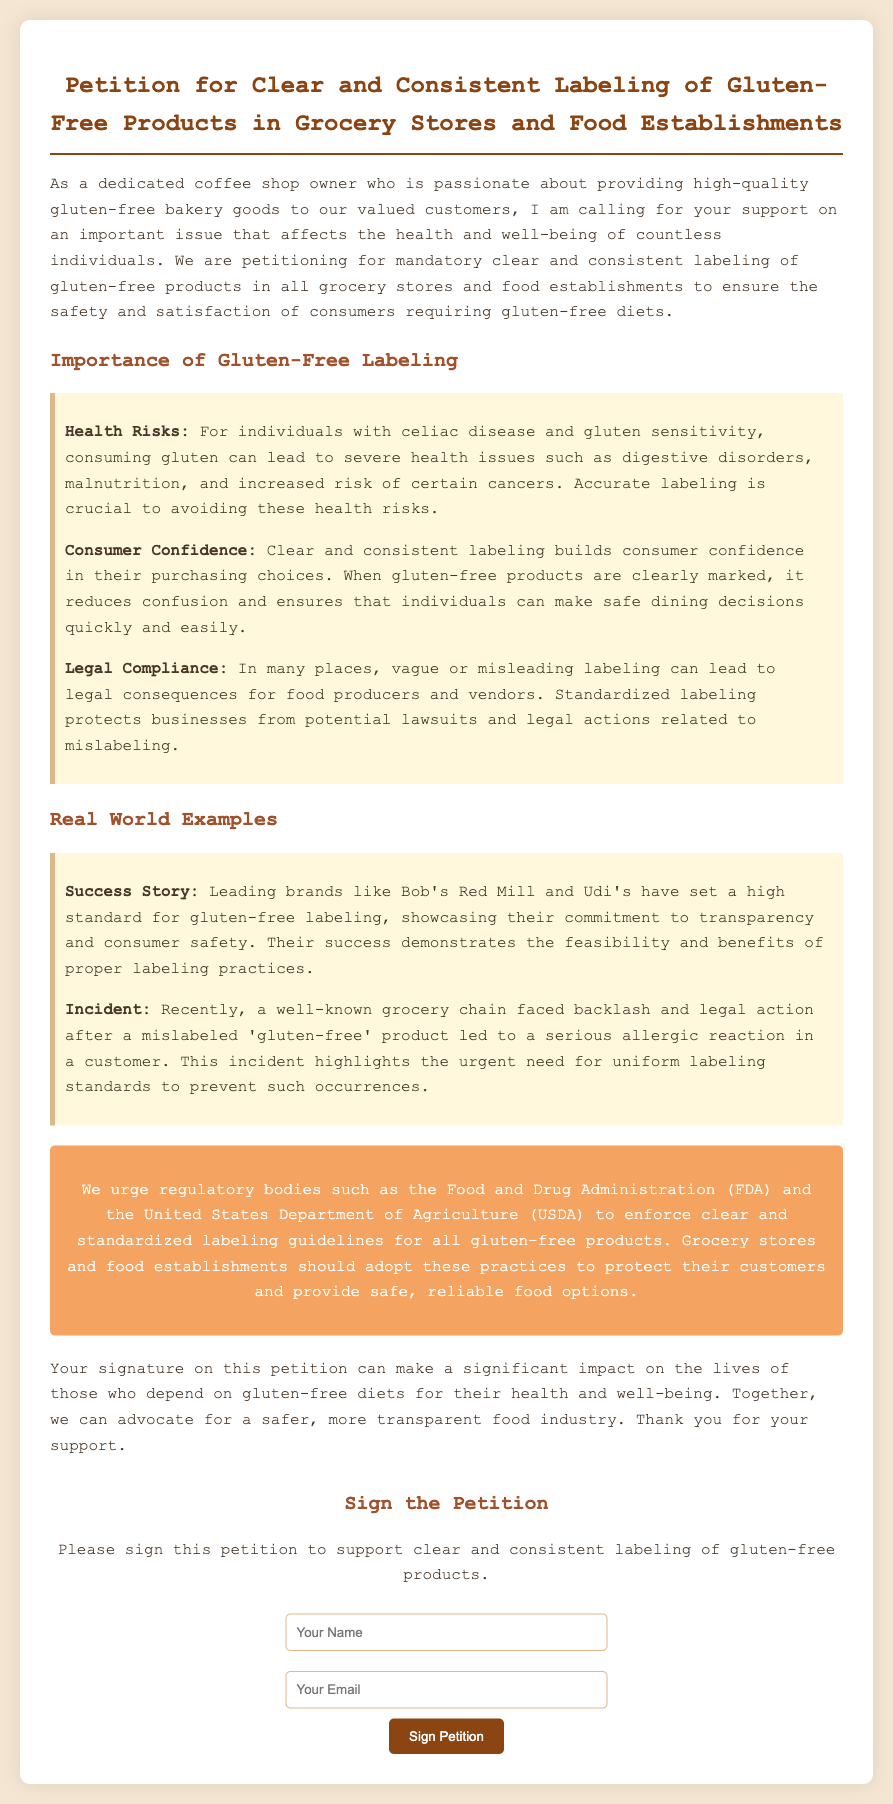What is the title of the petition? The title of the petition is stated in the header of the document.
Answer: Petition for Clear and Consistent Labeling of Gluten-Free Products in Grocery Stores and Food Establishments What are some health risks for individuals with gluten sensitivity? The document outlines specific health risks that individuals with gluten sensitivity may face.
Answer: Digestive disorders, malnutrition, and increased risk of certain cancers Which brands are mentioned as success stories for gluten-free labeling? The document provides examples of brands that have successfully implemented gluten-free labeling.
Answer: Bob's Red Mill and Udi's What does the call-to-action urge regulatory bodies to do? The call-to-action section specifies what is being requested from regulatory bodies.
Answer: Enforce clear and standardized labeling guidelines for all gluten-free products How many specific examples are provided in the section on real-world examples? The document includes a count of examples related to gluten-free labeling practices.
Answer: Two What type of form is included in the petition? The petition includes a specific element used to gather signatures.
Answer: A signature form What color is the background of the petition document? The background color is mentioned in the style section of the document.
Answer: Light brown (#f5e6d3) What main benefit does clear labeling provide to consumers? The petition outlines a key benefit of clear labeling for consumers.
Answer: Consumer confidence 